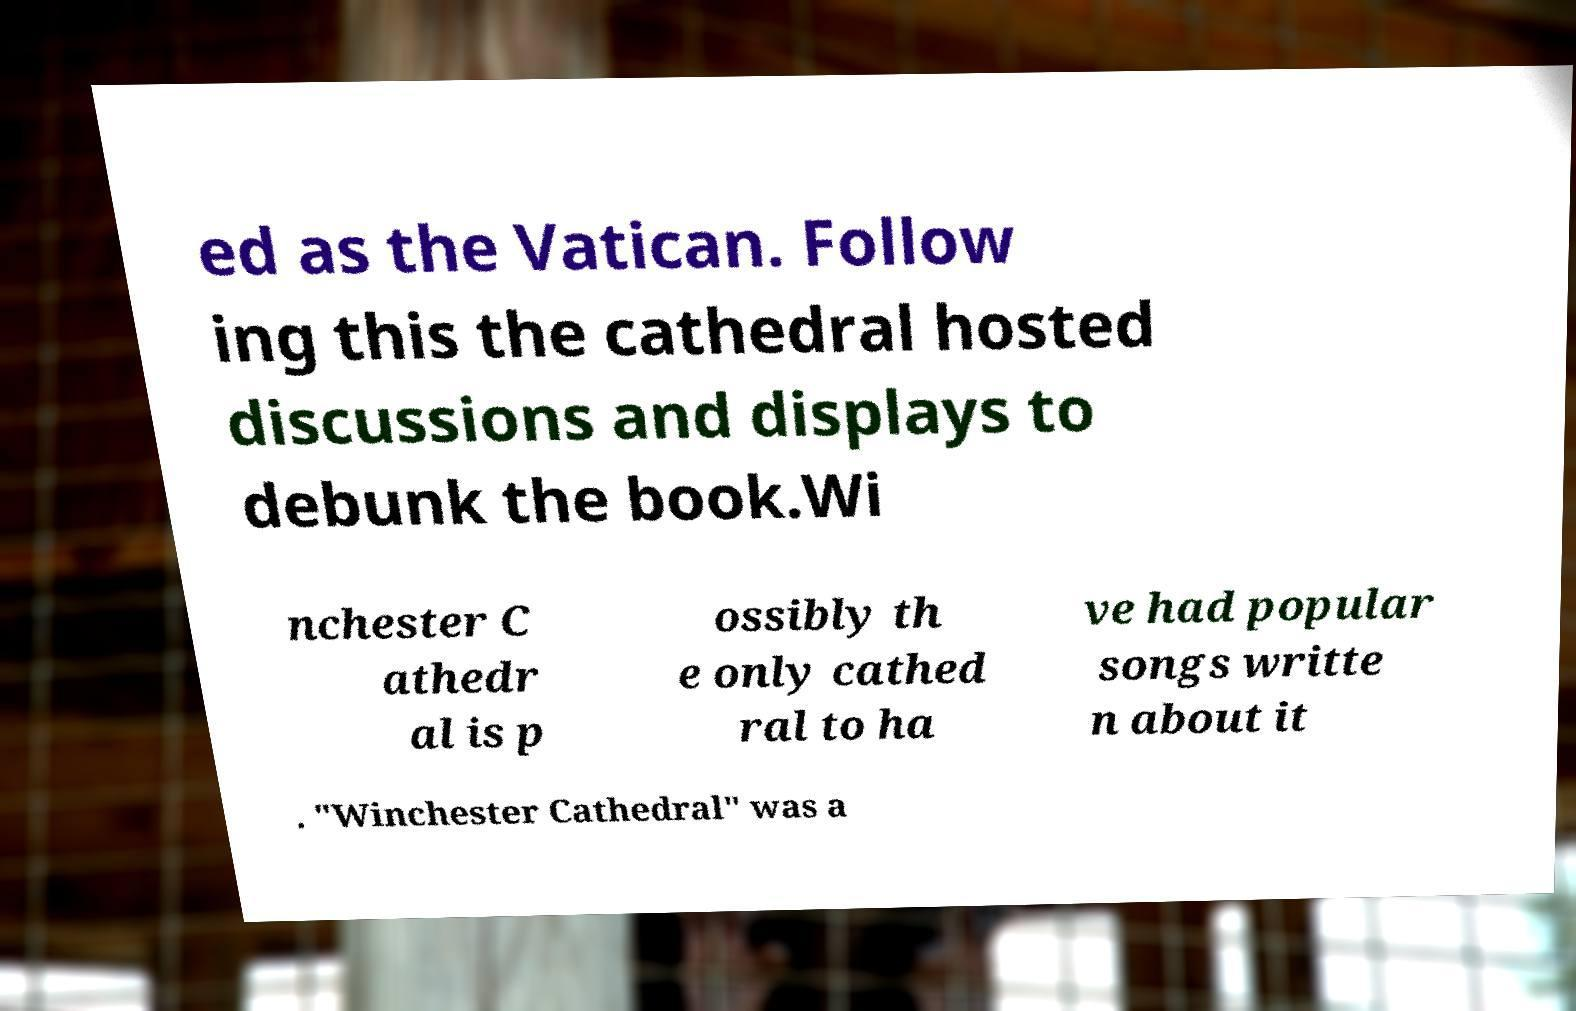Could you extract and type out the text from this image? ed as the Vatican. Follow ing this the cathedral hosted discussions and displays to debunk the book.Wi nchester C athedr al is p ossibly th e only cathed ral to ha ve had popular songs writte n about it . "Winchester Cathedral" was a 